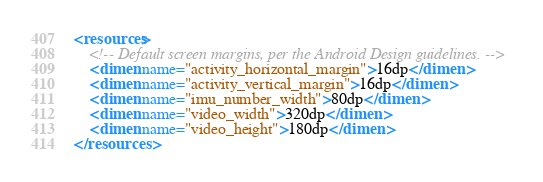<code> <loc_0><loc_0><loc_500><loc_500><_XML_><resources>
    <!-- Default screen margins, per the Android Design guidelines. -->
    <dimen name="activity_horizontal_margin">16dp</dimen>
    <dimen name="activity_vertical_margin">16dp</dimen>
    <dimen name="imu_number_width">80dp</dimen>
    <dimen name="video_width">320dp</dimen>
    <dimen name="video_height">180dp</dimen>
</resources>
</code> 